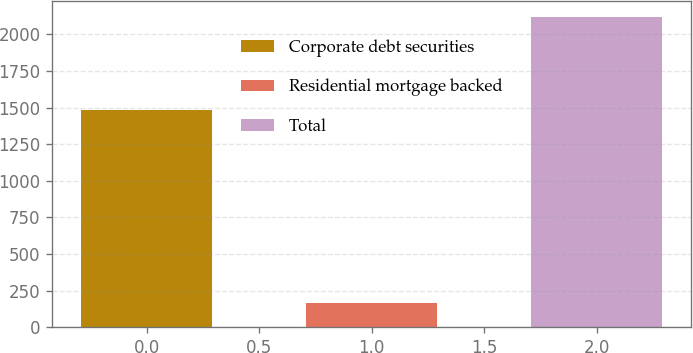Convert chart. <chart><loc_0><loc_0><loc_500><loc_500><bar_chart><fcel>Corporate debt securities<fcel>Residential mortgage backed<fcel>Total<nl><fcel>1482<fcel>168<fcel>2121<nl></chart> 